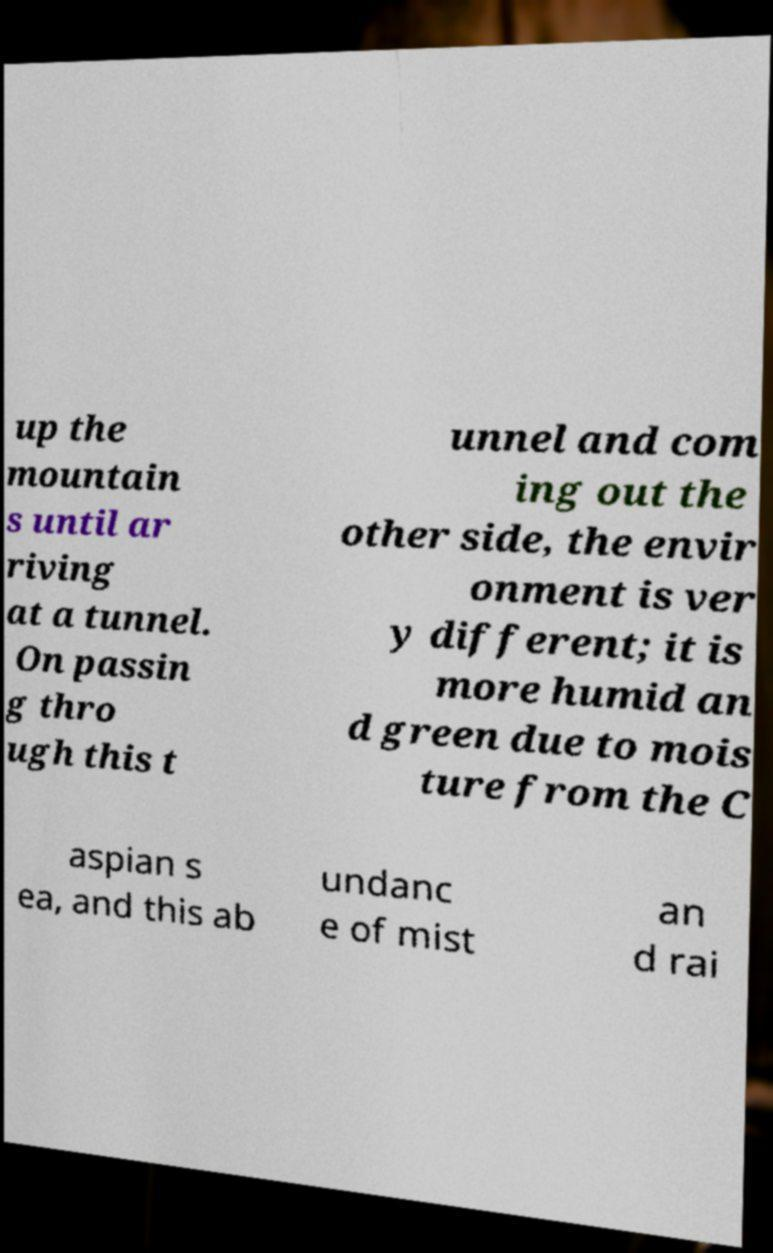What messages or text are displayed in this image? I need them in a readable, typed format. up the mountain s until ar riving at a tunnel. On passin g thro ugh this t unnel and com ing out the other side, the envir onment is ver y different; it is more humid an d green due to mois ture from the C aspian s ea, and this ab undanc e of mist an d rai 